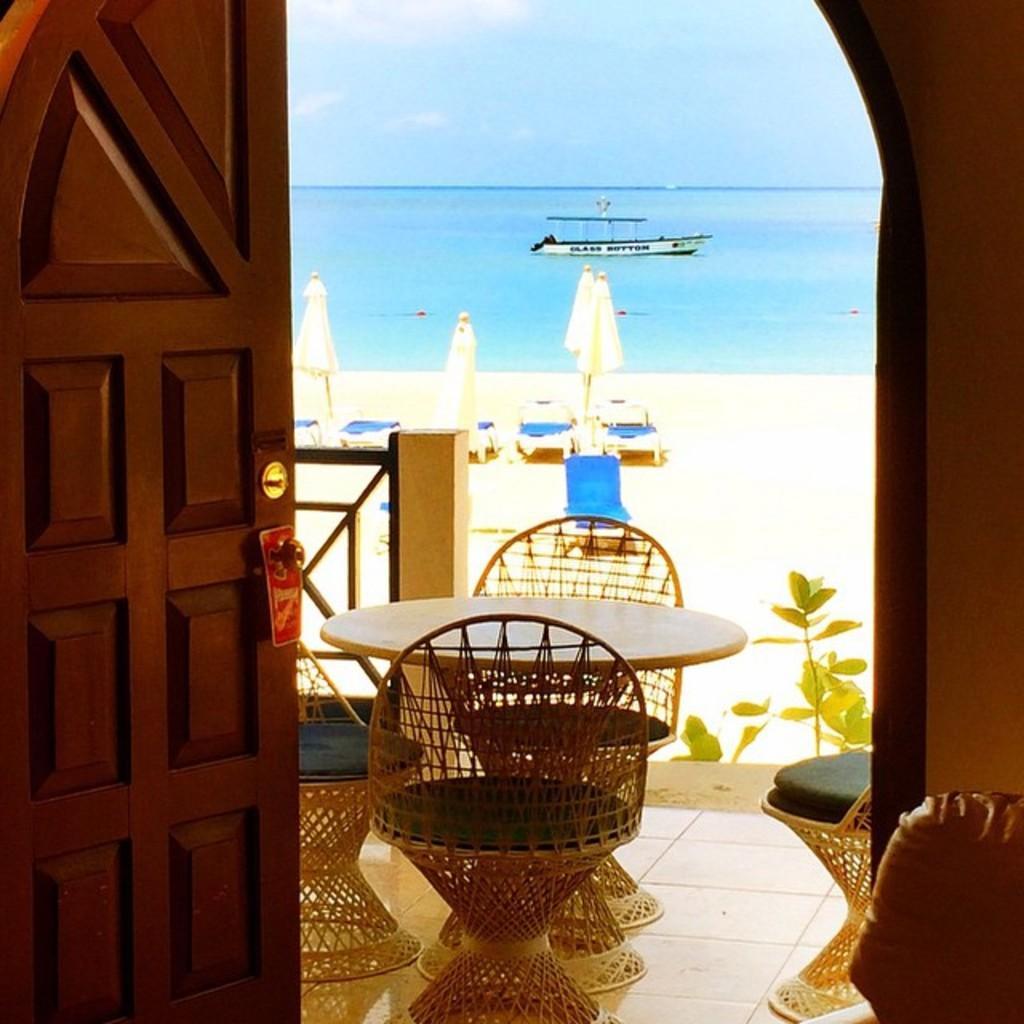Could you give a brief overview of what you see in this image? In this image we can see a door. There is a table and chairs. And there is a railing. Also there is a plant. In the back there is water. Also there are umbrellas. On the water there is a boat. In the background there is sky. 